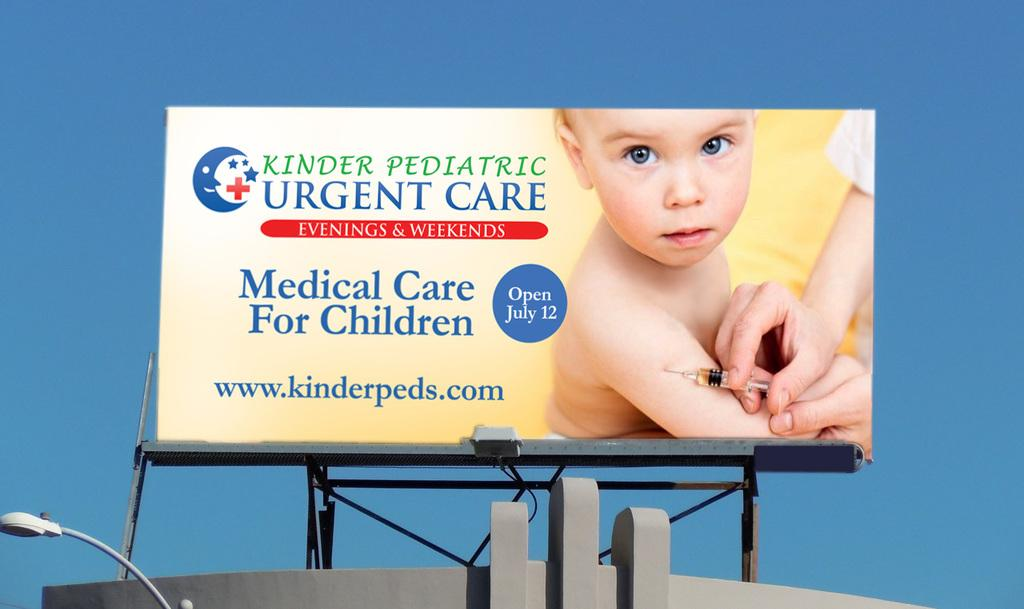<image>
Create a compact narrative representing the image presented. A huge poster of a nurse putting a injection on a baby that says Urgent Care. 